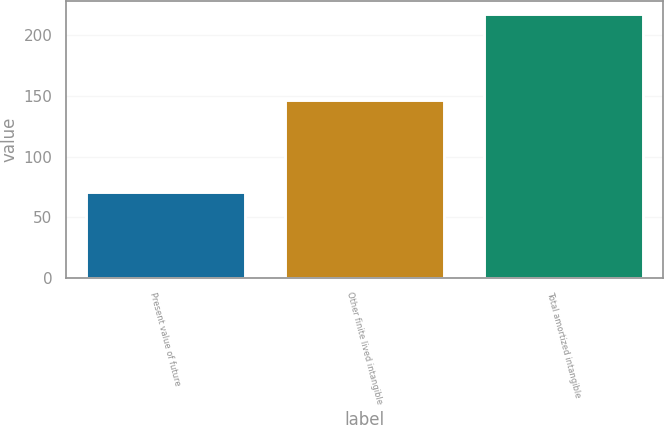Convert chart. <chart><loc_0><loc_0><loc_500><loc_500><bar_chart><fcel>Present value of future<fcel>Other finite lived intangible<fcel>Total amortized intangible<nl><fcel>70.7<fcel>147<fcel>217.7<nl></chart> 